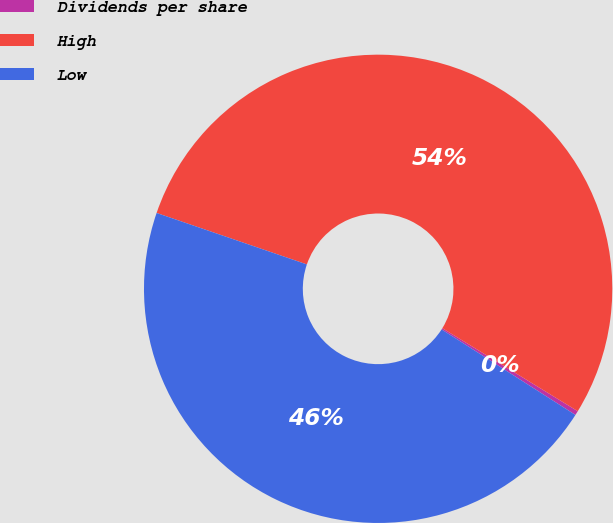<chart> <loc_0><loc_0><loc_500><loc_500><pie_chart><fcel>Dividends per share<fcel>High<fcel>Low<nl><fcel>0.3%<fcel>53.5%<fcel>46.2%<nl></chart> 